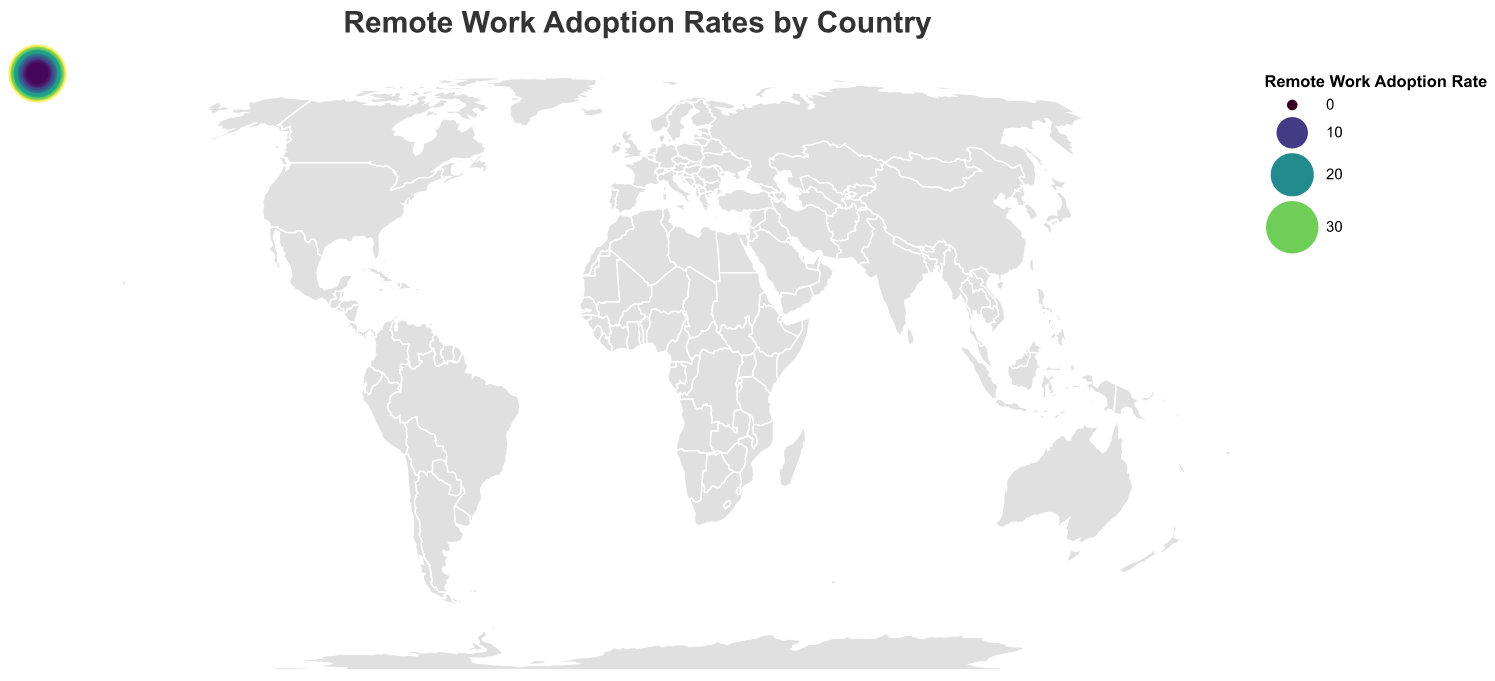What's the title of the figure? The title of the figure is displayed at the top of the plot. It reads "Remote Work Adoption Rates by Country."
Answer: Remote Work Adoption Rates by Country Which country has the highest remote work adoption rate? The data points are represented by circles, and the United States has the largest circle with the highest remote work adoption rate.
Answer: United States What is the remote work adoption rate for France? France's data point on the map shows a circle, which indicates a remote work adoption rate of 15.9.
Answer: 15.9 Which country has a lower remote work adoption rate, Mexico or Brazil? Comparing the sizes of the circles and their coloring, Mexico has a smaller and differently colored circle indicating a lower adoption rate than Brazil.
Answer: Mexico How many countries have a remote work adoption rate above 20%? To find this, count the number of circles representing countries with a rate above 20. These countries are United States, United Kingdom, Canada, Australia, Germany, Netherlands, Sweden, and Switzerland.
Answer: 8 What's the difference in remote work adoption rates between Sweden and Switzerland? Sweden has a remote work adoption rate of 23.5, and Switzerland has 22.1. The difference is 23.5 - 22.1.
Answer: 1.4 Which continent has the highest average remote work adoption rate based on this data? To determine the continent with the highest average rate, aggregate the data points visually by continent. Notably, North America (United States, Canada, Mexico) has high rates. United States and Canada have rates of 37.2 and 30.8, while Mexico has 7.2.
Answer: North America Which country has the smallest remote work adoption rate? The smallest circle represents Nigeria, indicating it has the smallest remote work adoption rate.
Answer: Nigeria How does the remote work adoption rate of Germany compare to Japan? Comparing the circles for Germany and Japan, Germany has a larger circle indicating a higher remote work adoption rate of 25.6 compared to Japan's 16.8.
Answer: Germany has a higher rate What is the total remote work adoption rate for the countries listed? Add the remote work adoption rates for all 20 countries: 37.2 + 32.5 + 30.8 + 28.9 + 25.6 + 24.7 + 23.5 + 22.1 + 16.8 + 15.9 + 14.7 + 12.3 + 11.6 + 10.8 + 8.5 + 7.9 + 7.2 + 6.5 + 5.8 + 4.3 = 347.6.
Answer: 347.6 